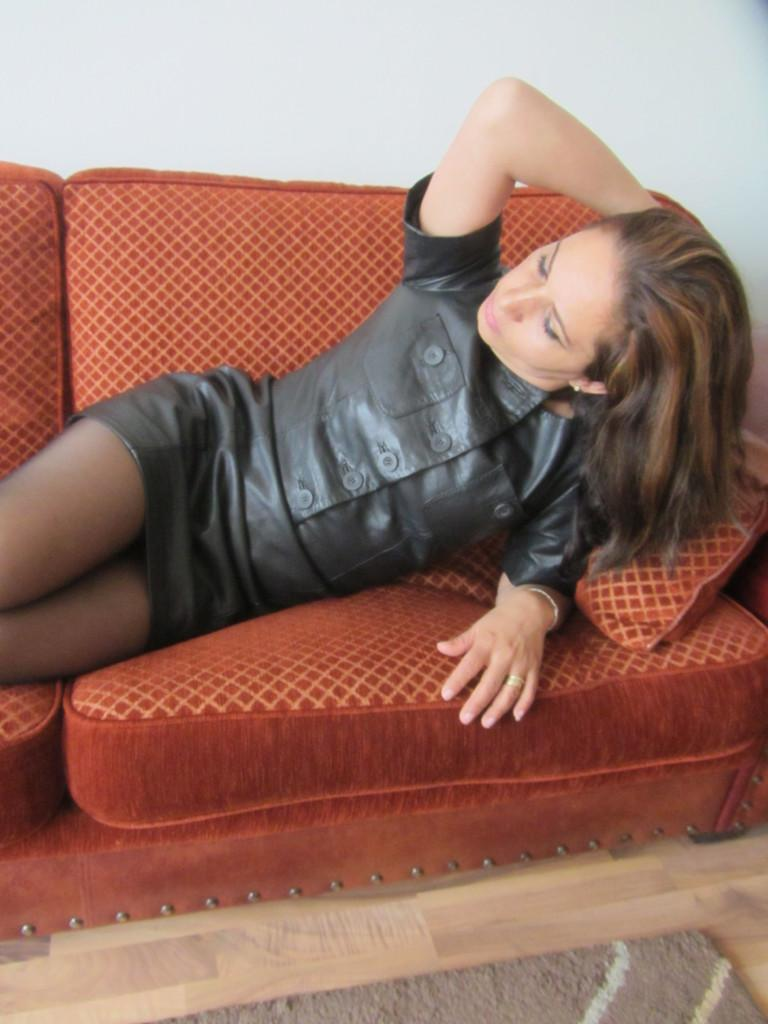Who is present in the image? There is a woman in the image. What is the woman doing in the image? The woman is lying on a sofa. What can be seen in the background of the image? There is a wall in the background of the image. What arithmetic problem is the woman solving on the sofa? There is no indication in the image that the woman is solving an arithmetic problem, as she is simply lying on the sofa. Is there a servant present in the image? There is no mention of a servant in the image, and no such figure can be seen. 